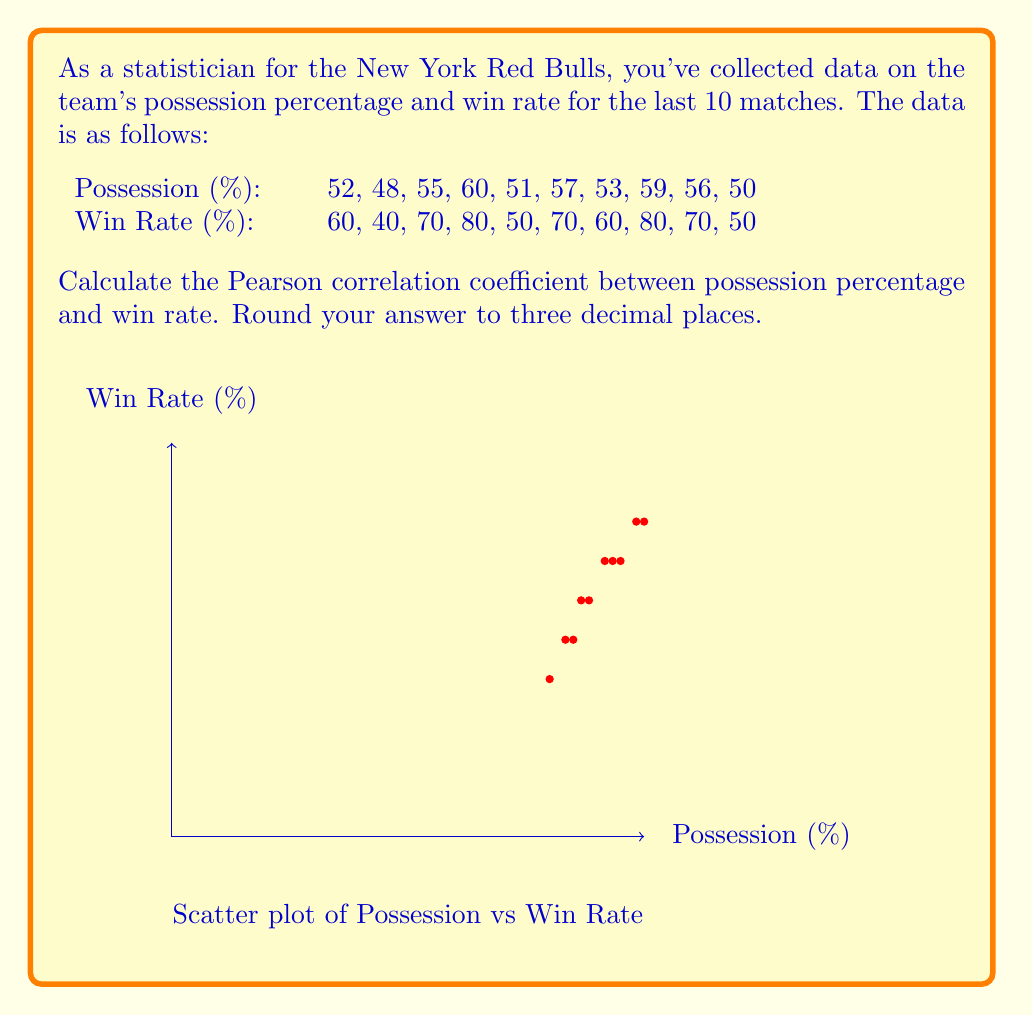Give your solution to this math problem. To calculate the Pearson correlation coefficient (r), we'll use the formula:

$$ r = \frac{\sum_{i=1}^{n} (x_i - \bar{x})(y_i - \bar{y})}{\sqrt{\sum_{i=1}^{n} (x_i - \bar{x})^2 \sum_{i=1}^{n} (y_i - \bar{y})^2}} $$

Where $x_i$ are the possession percentages, $y_i$ are the win rates, and $\bar{x}$ and $\bar{y}$ are their respective means.

Step 1: Calculate the means
$\bar{x} = \frac{52 + 48 + 55 + 60 + 51 + 57 + 53 + 59 + 56 + 50}{10} = 54.1$
$\bar{y} = \frac{60 + 40 + 70 + 80 + 50 + 70 + 60 + 80 + 70 + 50}{10} = 63$

Step 2: Calculate $(x_i - \bar{x})$, $(y_i - \bar{y})$, $(x_i - \bar{x})^2$, $(y_i - \bar{y})^2$, and $(x_i - \bar{x})(y_i - \bar{y})$ for each data point.

Step 3: Sum up the results from Step 2
$\sum (x_i - \bar{x})(y_i - \bar{y}) = 332.9$
$\sum (x_i - \bar{x})^2 = 157.9$
$\sum (y_i - \bar{y})^2 = 1490$

Step 4: Apply the formula
$$ r = \frac{332.9}{\sqrt{157.9 \times 1490}} = \frac{332.9}{485.3} \approx 0.686 $$
Answer: $0.686$ 